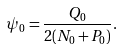<formula> <loc_0><loc_0><loc_500><loc_500>\psi _ { 0 } = \frac { Q _ { 0 } } { 2 ( N _ { 0 } + P _ { 0 } ) } .</formula> 